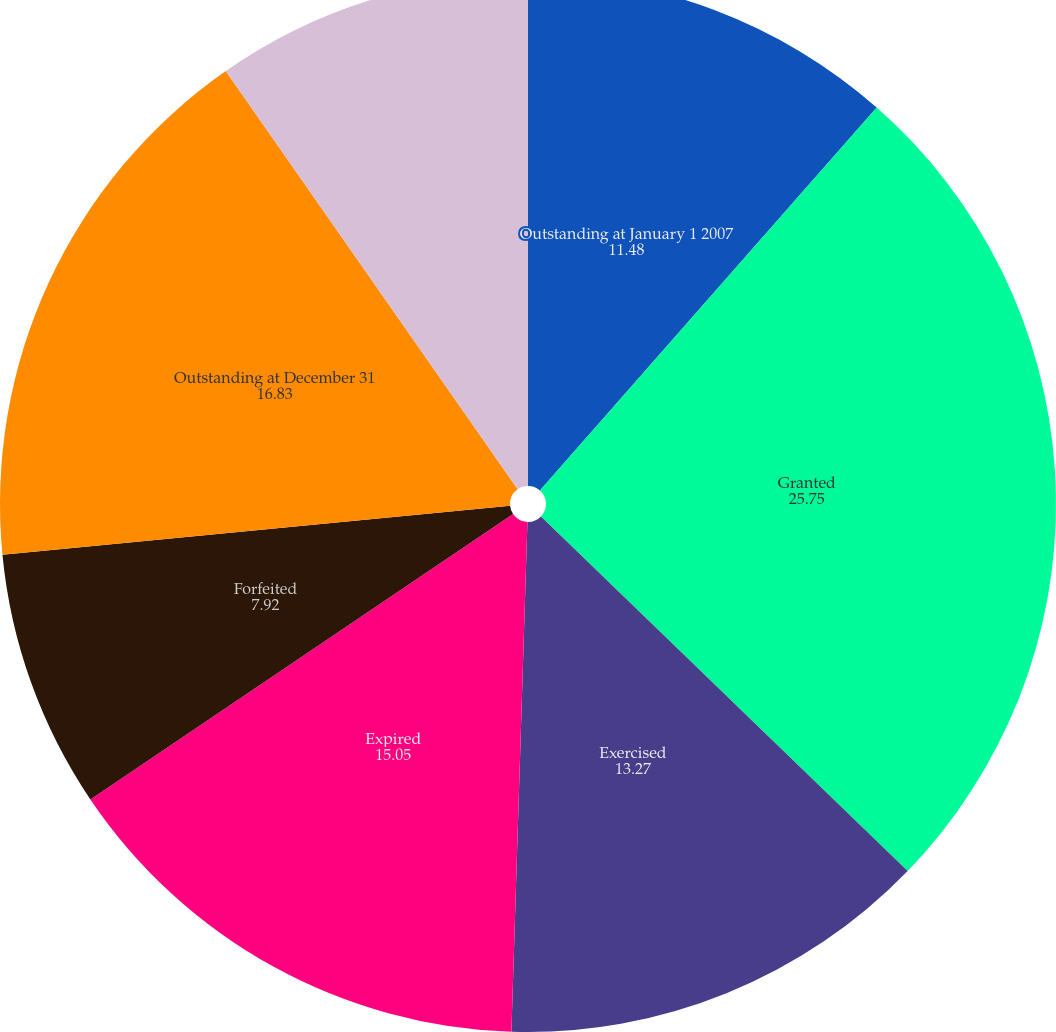<chart> <loc_0><loc_0><loc_500><loc_500><pie_chart><fcel>Outstanding at January 1 2007<fcel>Granted<fcel>Exercised<fcel>Expired<fcel>Forfeited<fcel>Outstanding at December 31<fcel>Exercisable at December 31<nl><fcel>11.48%<fcel>25.75%<fcel>13.27%<fcel>15.05%<fcel>7.92%<fcel>16.83%<fcel>9.7%<nl></chart> 